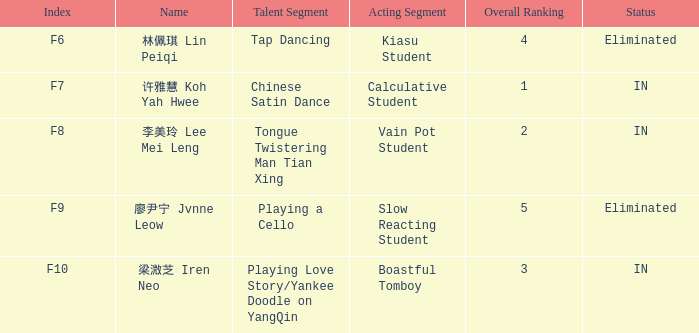What's the total number of overall rankings of 廖尹宁 jvnne leow's events that are eliminated? 1.0. 